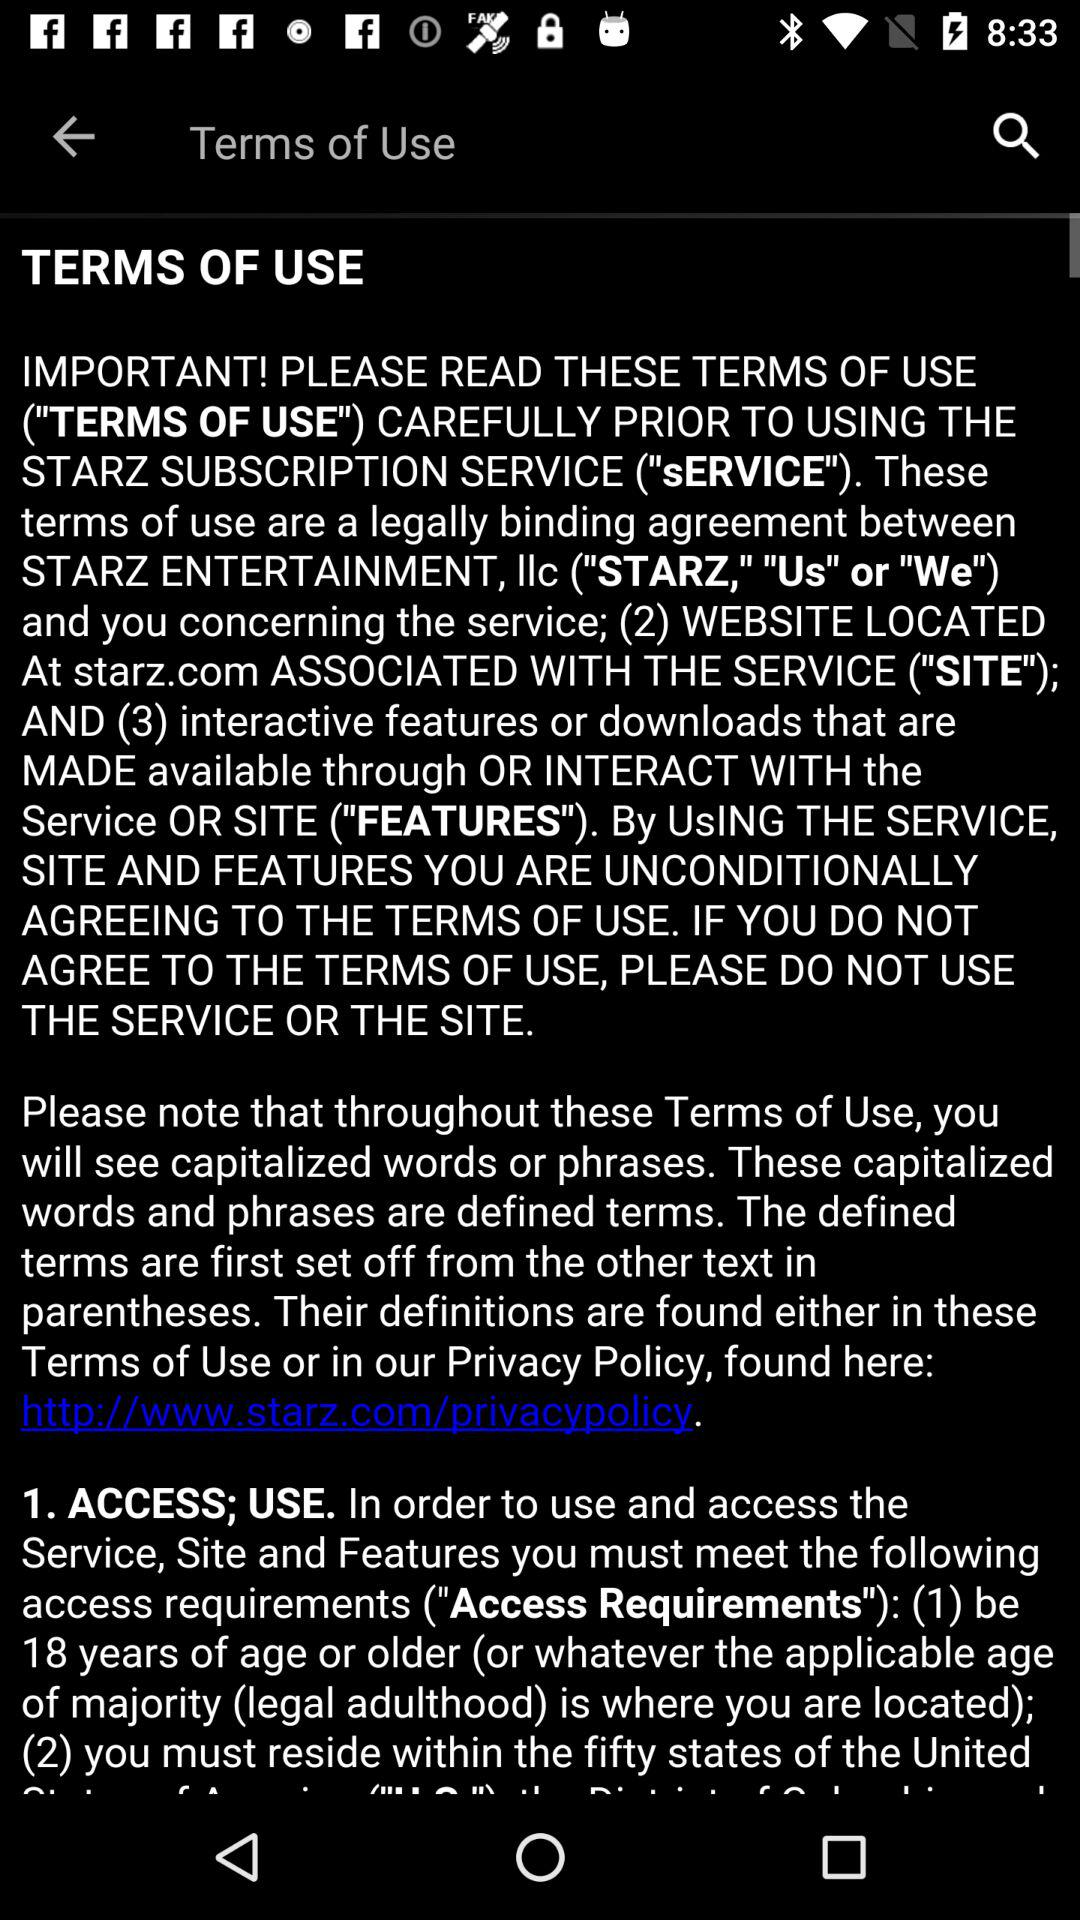What is the required minimum age to access the service? The required minimum age to access the service is 18 years. 